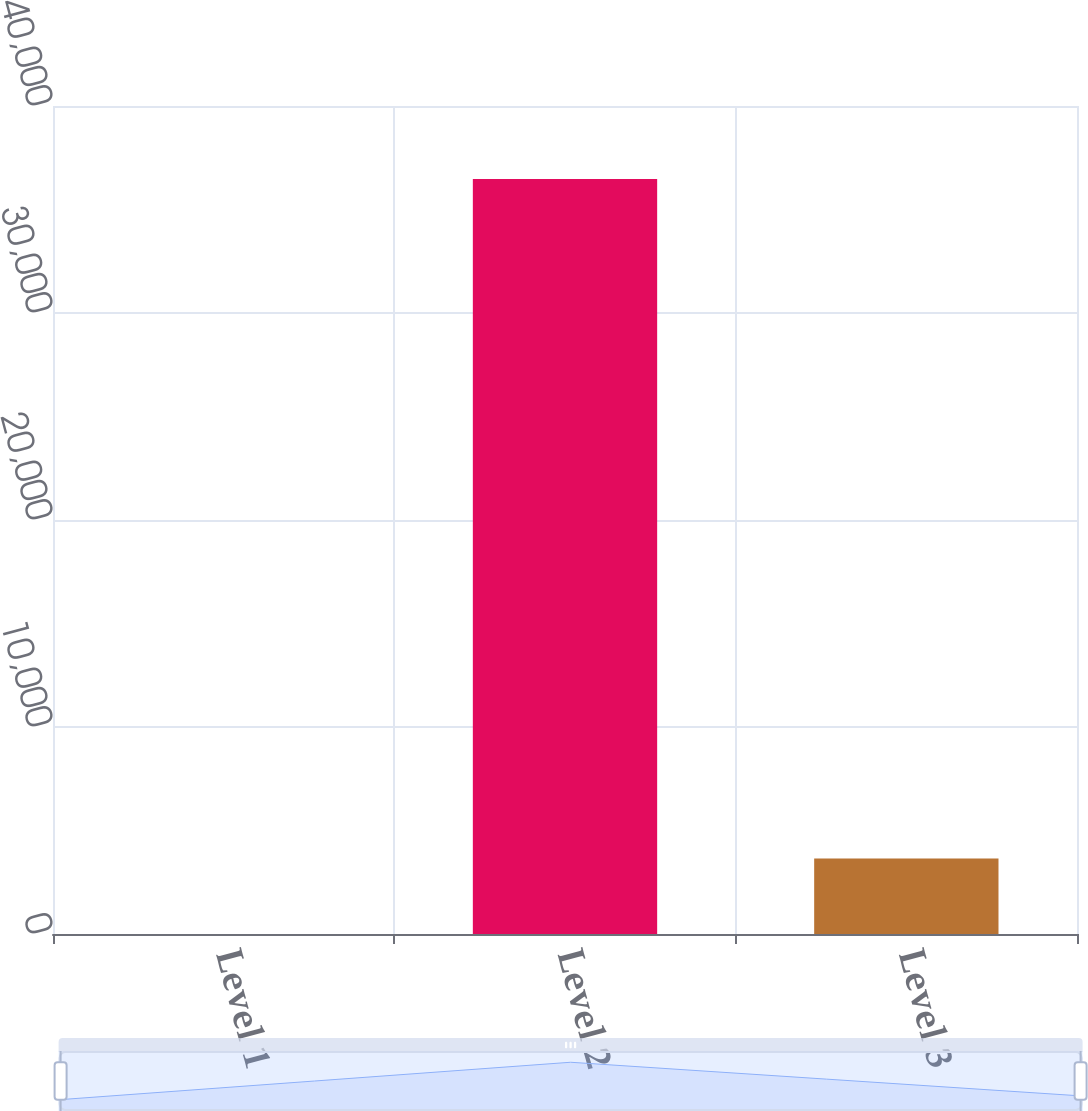<chart> <loc_0><loc_0><loc_500><loc_500><bar_chart><fcel>Level 1<fcel>Level 2<fcel>Level 3<nl><fcel>2.44<fcel>36468<fcel>3649<nl></chart> 